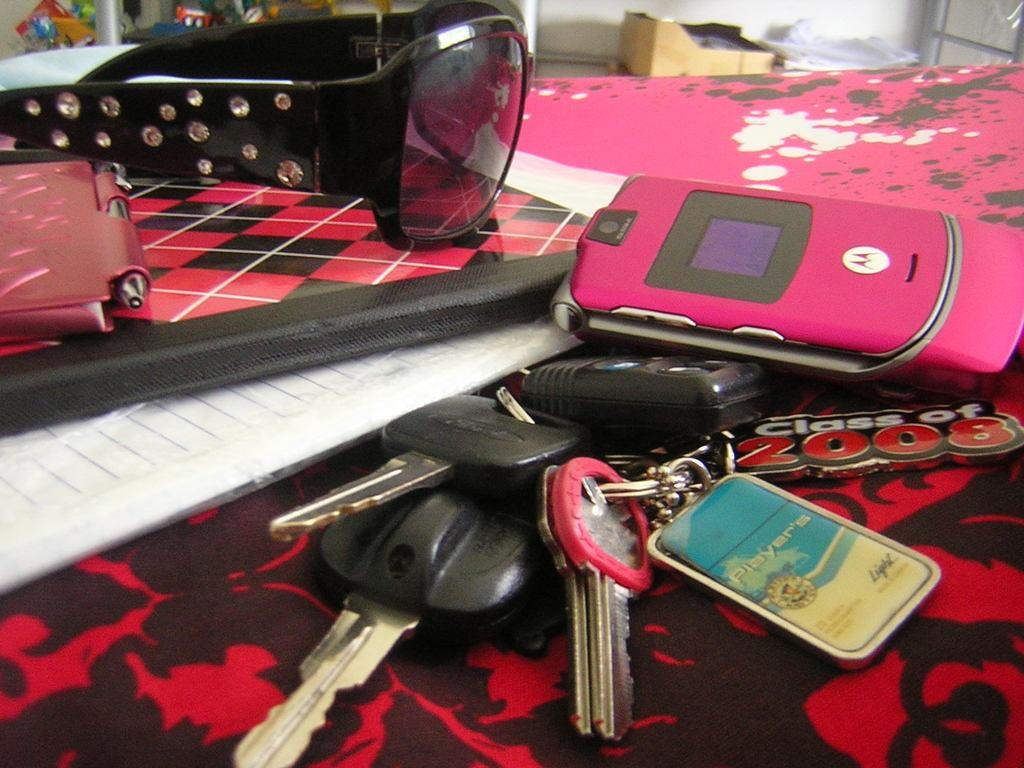What objects can be seen in the image? There are keys, a mobile, sunglasses, a paper on the table, a carton box, and additional papers in the image. Can you describe the mobile in the image? The mobile is a device that can be used for communication and other purposes. What might be used for vision protection in the image? Sunglasses are present in the image for vision protection. What is the paper on the table used for? The paper on the table might be used for writing or reading. What is the carton box used for? The carton box might be used for storage or transportation of items. What type of trail can be seen in the image? There is no trail present in the image. What is the point of the jar in the image? There is no jar present in the image, so it is not possible to determine its purpose or function. 